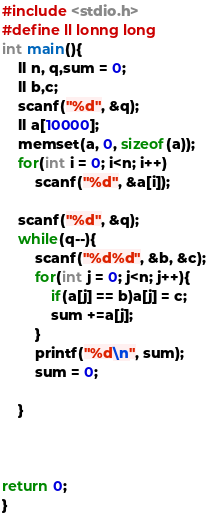<code> <loc_0><loc_0><loc_500><loc_500><_C_>#include <stdio.h>
#define ll lonng long
int main(){
	ll n, q,sum = 0;
	ll b,c;
	scanf("%d", &q);
	ll a[10000];
	memset(a, 0, sizeof(a));
	for(int i = 0; i<n; i++)
		scanf("%d", &a[i]);
	
	scanf("%d", &q);
	while(q--){
		scanf("%d%d", &b, &c); 
		for(int j = 0; j<n; j++){
			if(a[j] == b)a[j] = c;
			sum +=a[j]; 
		}
		printf("%d\n", sum);
		sum = 0;
	
	}
	
	

return 0;
}
</code> 